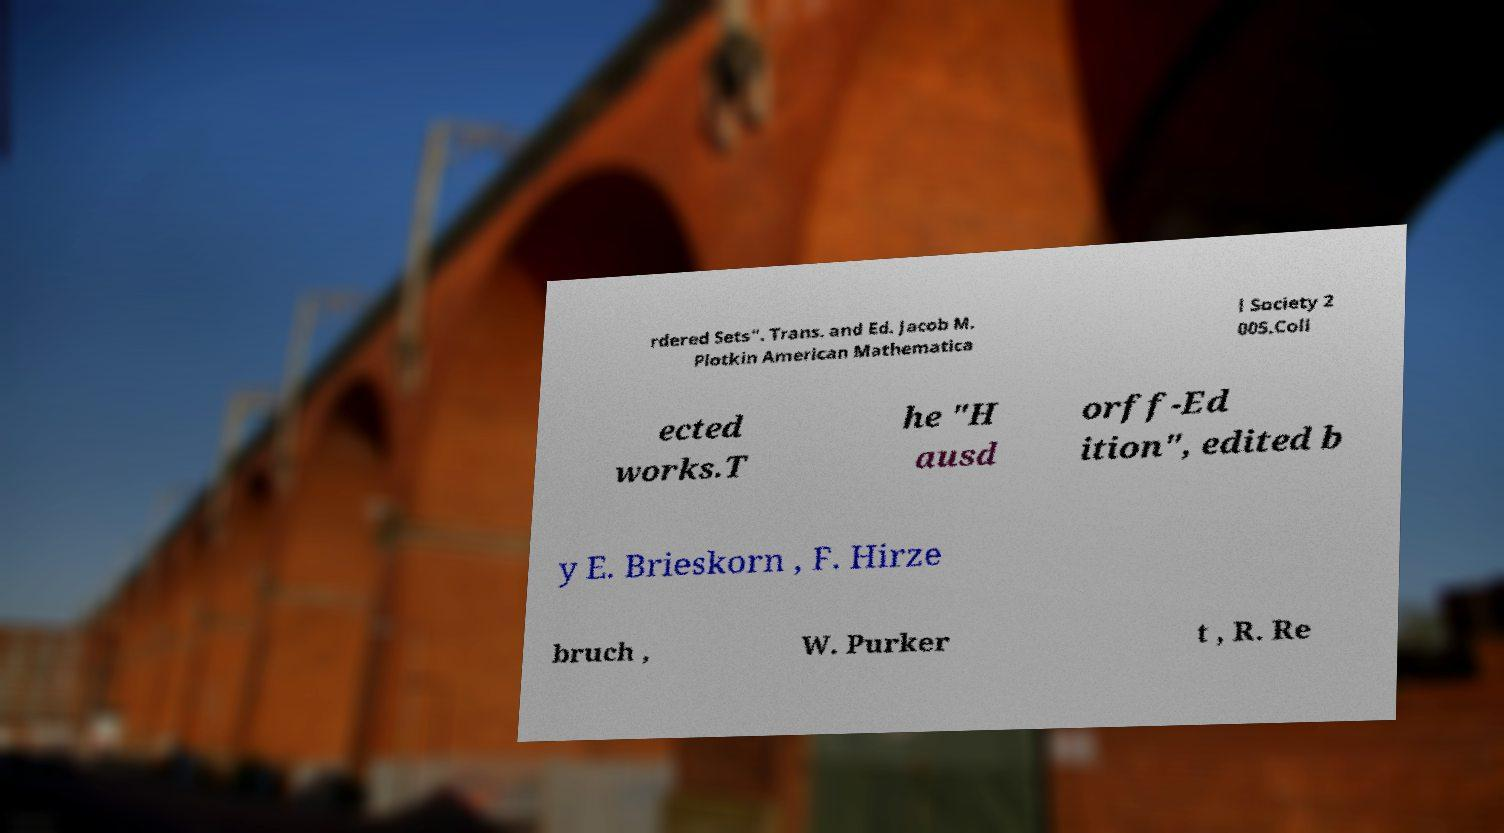Could you extract and type out the text from this image? rdered Sets". Trans. and Ed. Jacob M. Plotkin American Mathematica l Society 2 005.Coll ected works.T he "H ausd orff-Ed ition", edited b y E. Brieskorn , F. Hirze bruch , W. Purker t , R. Re 